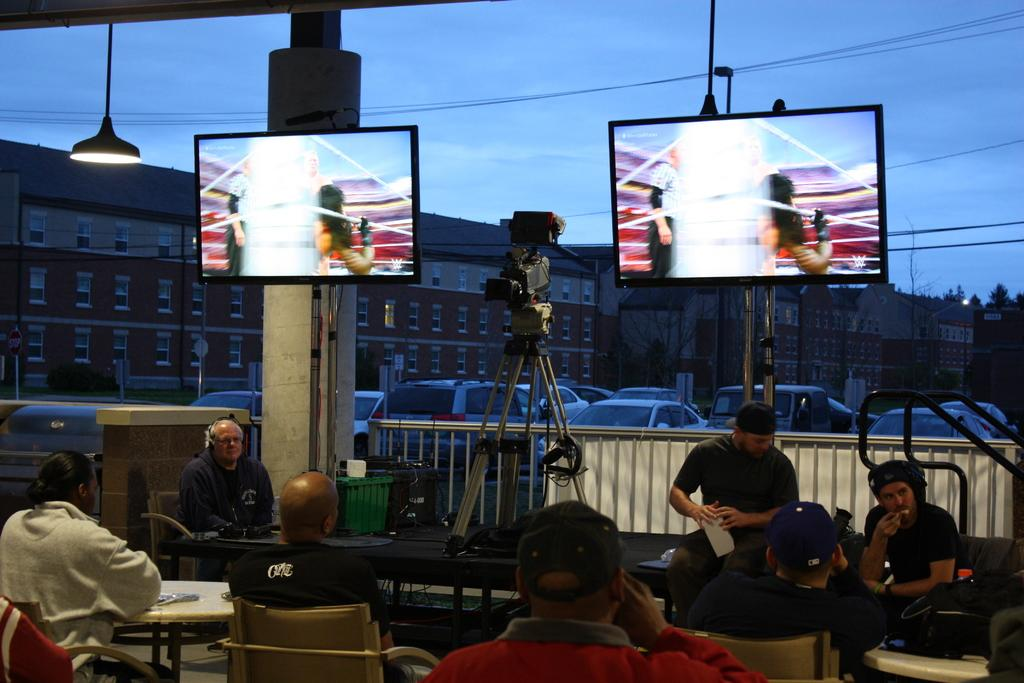What are the people in the image doing? There is a group of people sitting in the image. What object is present that is typically used for capturing images? There is a camera in the image. How many screens can be seen in the image? There are two screens in the image. What can be seen in the background of the image? There are vehicles, buildings, and trees in the background of the image. What color is the sky in the image? The sky is blue in the image. What type of oven is being used to cook the owl in the image? There is no oven or owl present in the image; it features a group of people sitting, a camera, screens, and a background with vehicles, buildings, trees, and a blue sky. 